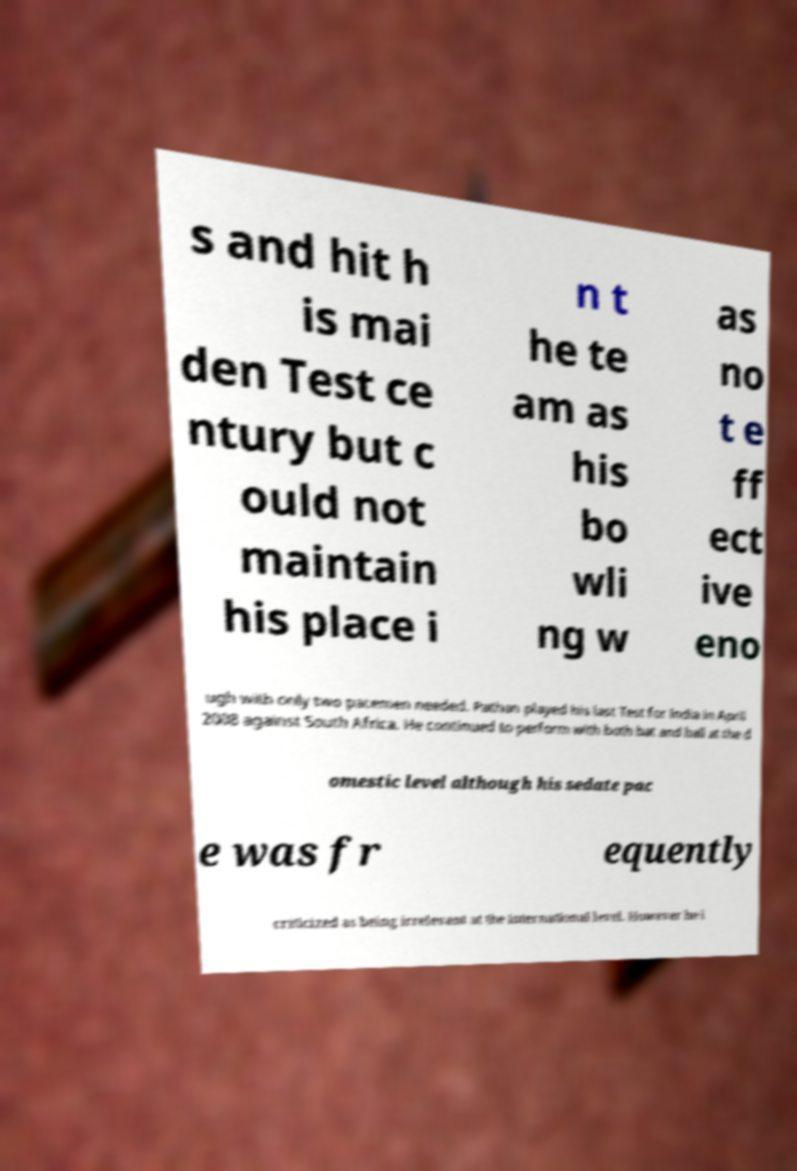Could you extract and type out the text from this image? s and hit h is mai den Test ce ntury but c ould not maintain his place i n t he te am as his bo wli ng w as no t e ff ect ive eno ugh with only two pacemen needed. Pathan played his last Test for India in April 2008 against South Africa. He continued to perform with both bat and ball at the d omestic level although his sedate pac e was fr equently criticized as being irrelevant at the international level. However he i 